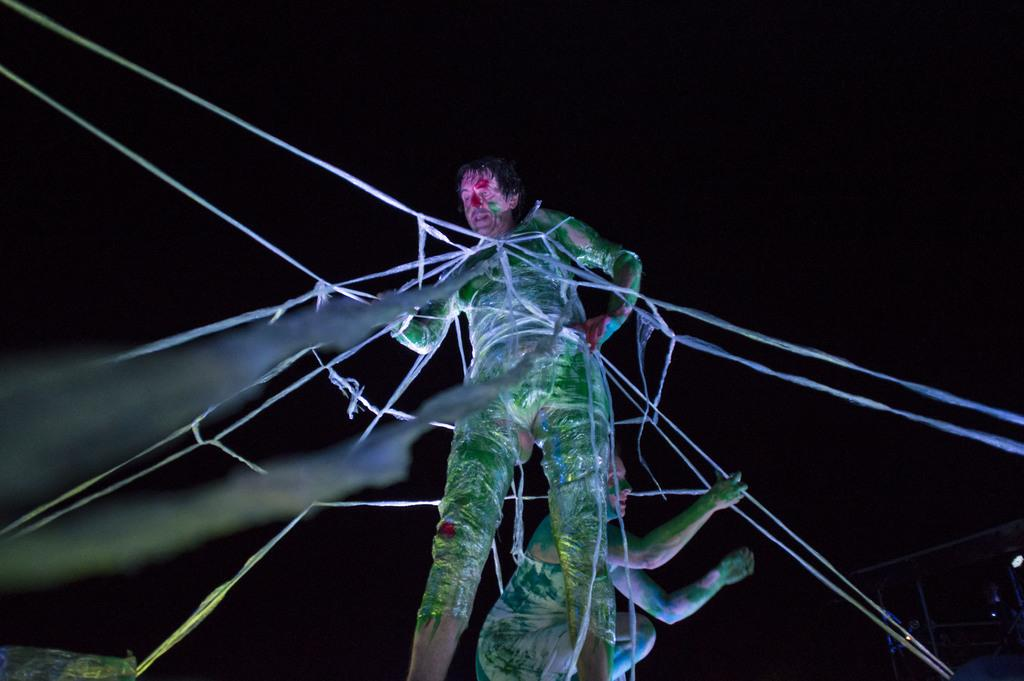What is happening to the person in the image? The person is tied with ropes with ropes in the image. Who is holding the ropes in the image? There is another person holding the ropes in the image. What can be observed about the lighting in the image? The background of the image is dark. How does the person compare their situation to the things they have experienced before? The image does not provide any information about the person's thoughts or past experiences, so it is not possible to answer this question. 